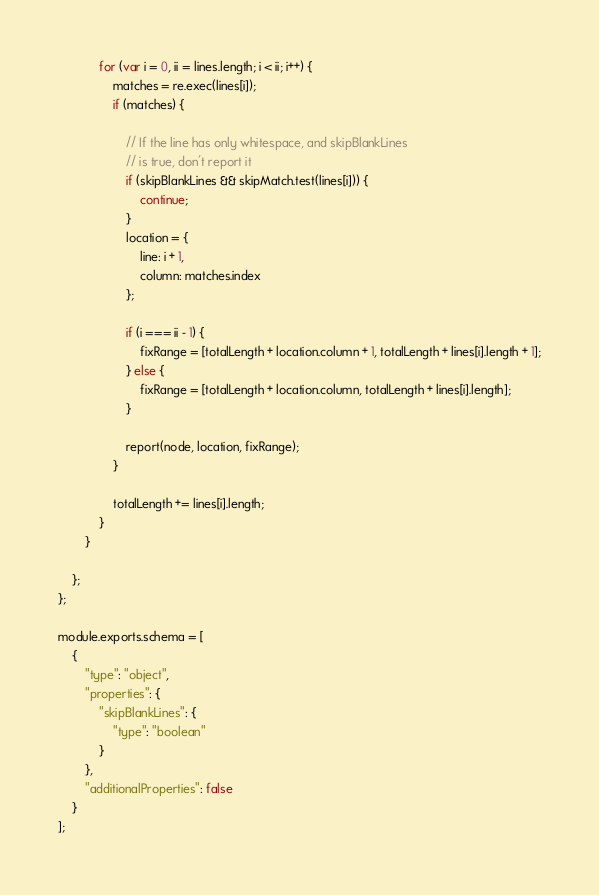<code> <loc_0><loc_0><loc_500><loc_500><_JavaScript_>
            for (var i = 0, ii = lines.length; i < ii; i++) {
                matches = re.exec(lines[i]);
                if (matches) {

                    // If the line has only whitespace, and skipBlankLines
                    // is true, don't report it
                    if (skipBlankLines && skipMatch.test(lines[i])) {
                        continue;
                    }
                    location = {
                        line: i + 1,
                        column: matches.index
                    };

                    if (i === ii - 1) {
                        fixRange = [totalLength + location.column + 1, totalLength + lines[i].length + 1];
                    } else {
                        fixRange = [totalLength + location.column, totalLength + lines[i].length];
                    }

                    report(node, location, fixRange);
                }

                totalLength += lines[i].length;
            }
        }

    };
};

module.exports.schema = [
    {
        "type": "object",
        "properties": {
            "skipBlankLines": {
                "type": "boolean"
            }
        },
        "additionalProperties": false
    }
];
</code> 